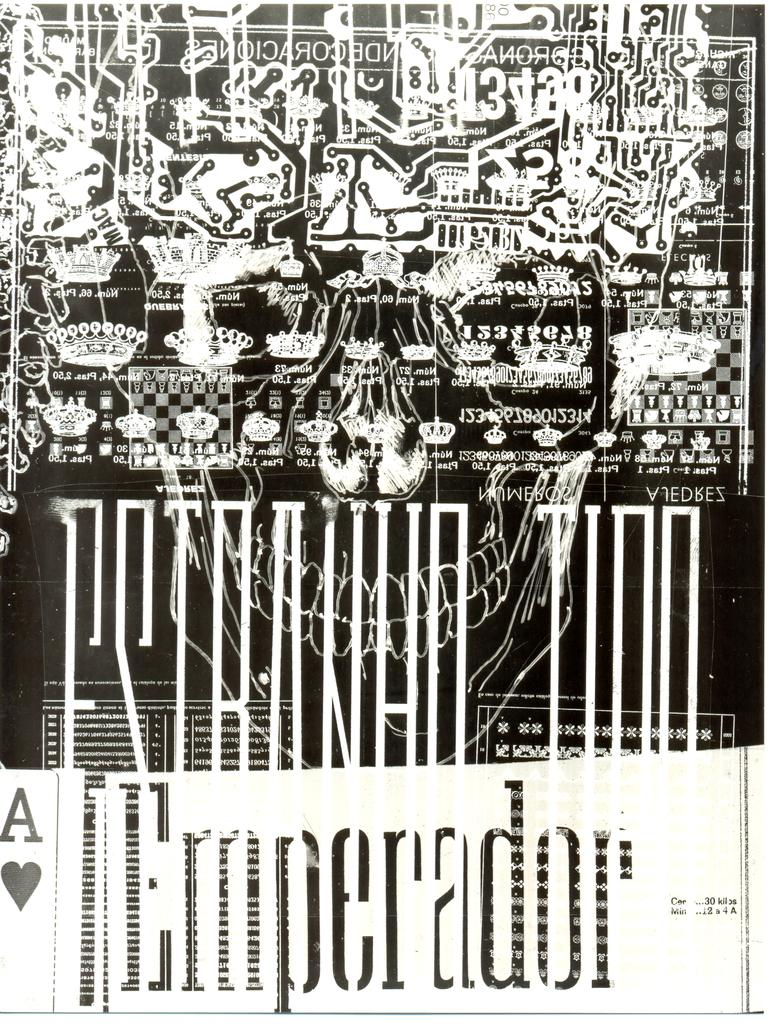<image>
Offer a succinct explanation of the picture presented. A black and white poster with an A of hearts on the bottom left. 